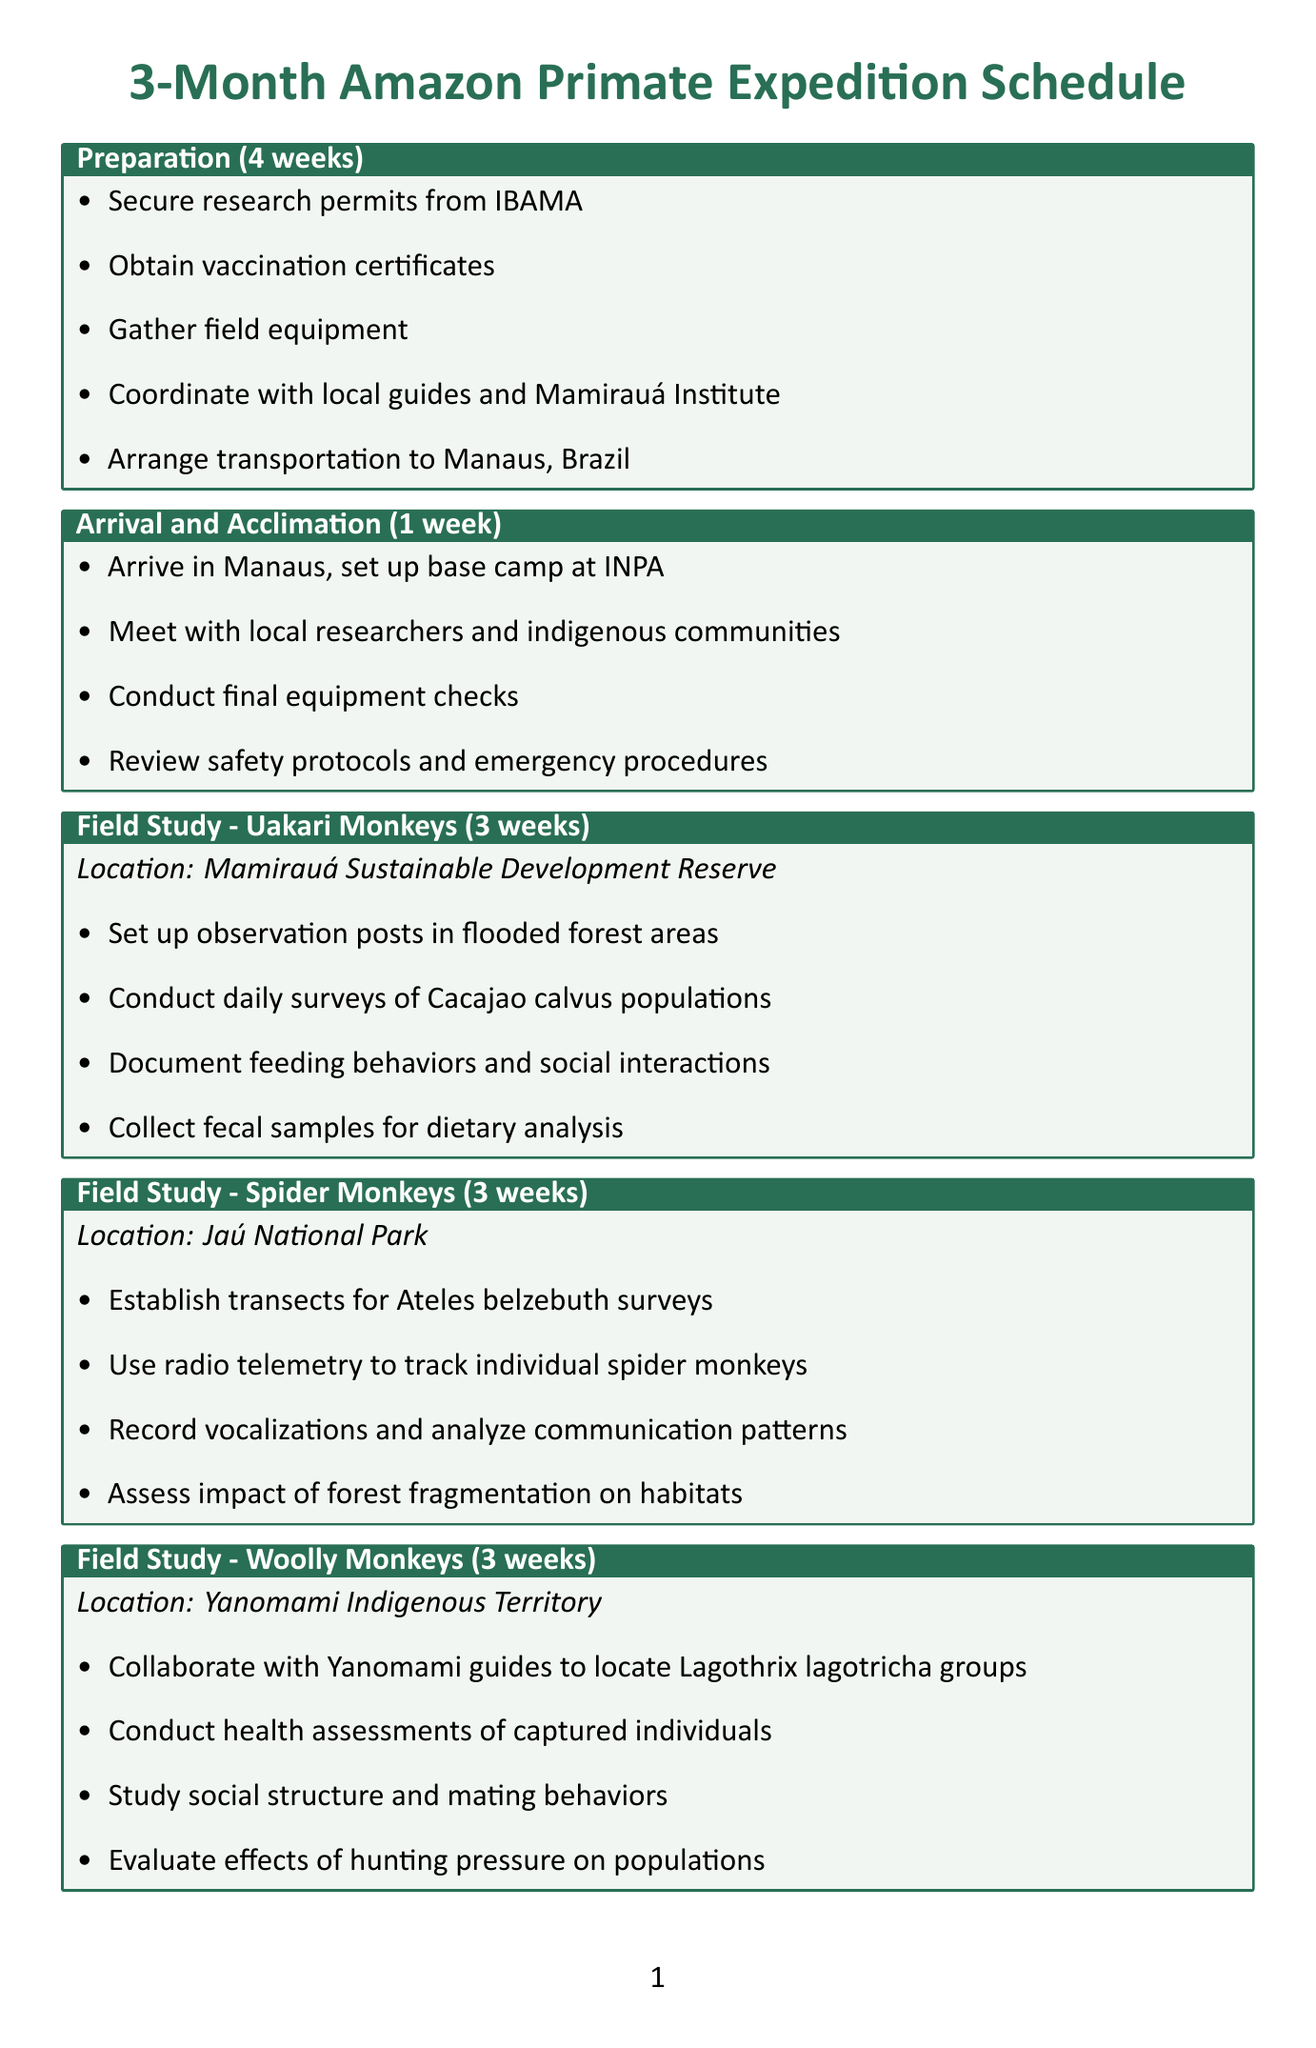What is the total duration of the expedition? The total duration includes the preparation, arrival, field studies, data analysis, and wrap-up phases, totaling 3 months or approximately 12 weeks.
Answer: 12 weeks How long is the field study for Uakari monkeys? The field study for Uakari monkeys is specifically detailed in the document and lasts for 3 weeks.
Answer: 3 weeks What is one of the essential equipment items listed? The document explicitly lists various items, one of which is the Garmin GPSMAP 66sr handheld GPS device.
Answer: Garmin GPSMAP 66sr handheld GPS devices Who is a collaborator associated with WWF-Brazil? One key collaborator mentioned in the document is Dr. Fábio Röhe, who works for WWF-Brazil.
Answer: Dr. Fábio Röhe What phase follows the Arrival and Acclimation? The document outlines the phases in sequence, with the Field Study for Uakari monkeys coming next after Arrival and Acclimation.
Answer: Field Study - Uakari Monkeys What is one of the key research objectives? The researcher objectives in the document include assessing current population sizes of primate species, one of which is explicitly mentioned.
Answer: Assess current population sizes of Uakari, Spider, and Woolly monkeys How many weeks are allocated for data analysis and conservation planning? The document provides a specific duration of 2 weeks for data analysis and conservation planning phase.
Answer: 2 weeks Which location is designated for the Field Study of Woolly Monkeys? The document states that the Field Study for Woolly Monkeys takes place in the Yanomami Indigenous Territory.
Answer: Yanomami Indigenous Territory 